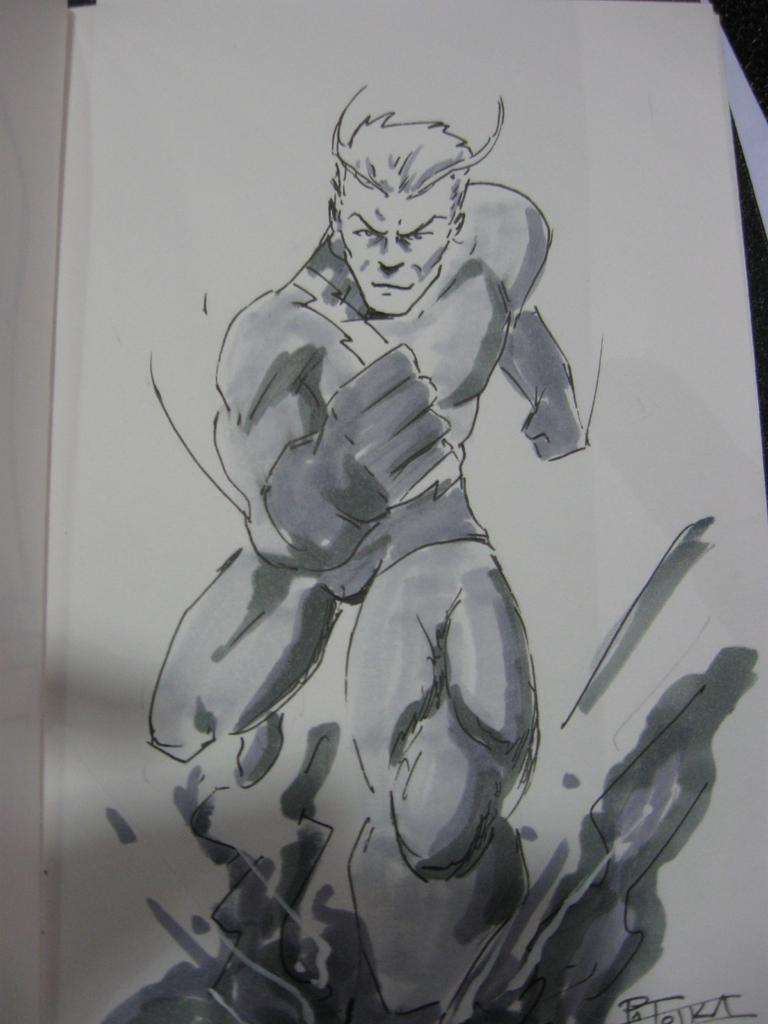What is depicted in the image? There is a diagram of a person in the image. How many kittens are playing with boats in the diagram? There are no kittens or boats present in the image; it features a diagram of a person. 